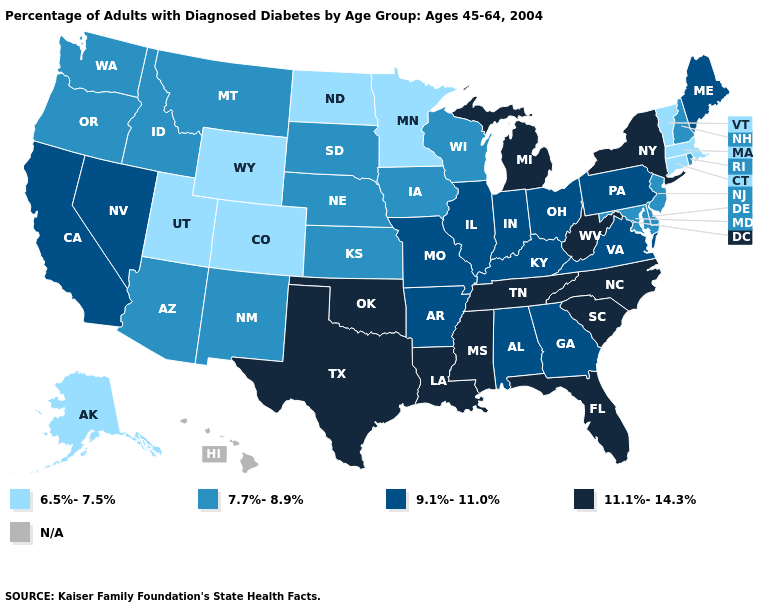Does the first symbol in the legend represent the smallest category?
Keep it brief. Yes. Is the legend a continuous bar?
Short answer required. No. Name the states that have a value in the range N/A?
Quick response, please. Hawaii. Does Oklahoma have the highest value in the USA?
Quick response, please. Yes. Is the legend a continuous bar?
Concise answer only. No. Name the states that have a value in the range 11.1%-14.3%?
Short answer required. Florida, Louisiana, Michigan, Mississippi, New York, North Carolina, Oklahoma, South Carolina, Tennessee, Texas, West Virginia. Which states have the highest value in the USA?
Short answer required. Florida, Louisiana, Michigan, Mississippi, New York, North Carolina, Oklahoma, South Carolina, Tennessee, Texas, West Virginia. What is the value of Oklahoma?
Answer briefly. 11.1%-14.3%. What is the value of New Jersey?
Answer briefly. 7.7%-8.9%. Which states have the lowest value in the USA?
Answer briefly. Alaska, Colorado, Connecticut, Massachusetts, Minnesota, North Dakota, Utah, Vermont, Wyoming. Is the legend a continuous bar?
Write a very short answer. No. Which states have the lowest value in the MidWest?
Keep it brief. Minnesota, North Dakota. What is the value of North Dakota?
Quick response, please. 6.5%-7.5%. 